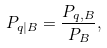Convert formula to latex. <formula><loc_0><loc_0><loc_500><loc_500>P _ { q | B } = \frac { P _ { q , B } } { P _ { B } } ,</formula> 